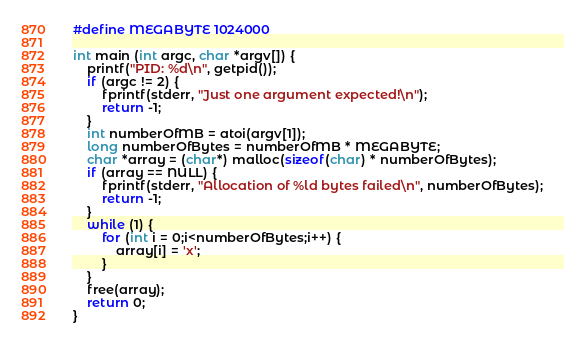Convert code to text. <code><loc_0><loc_0><loc_500><loc_500><_C_>
#define MEGABYTE 1024000

int main (int argc, char *argv[]) {
    printf("PID: %d\n", getpid());
    if (argc != 2) {
        fprintf(stderr, "Just one argument expected!\n");
        return -1;
    }
    int numberOfMB = atoi(argv[1]);
    long numberOfBytes = numberOfMB * MEGABYTE;
    char *array = (char*) malloc(sizeof(char) * numberOfBytes);
    if (array == NULL) {
        fprintf(stderr, "Allocation of %ld bytes failed\n", numberOfBytes);
        return -1;
    }
    while (1) {
        for (int i = 0;i<numberOfBytes;i++) {
            array[i] = 'x';
        }
    }
    free(array);
    return 0;
}</code> 